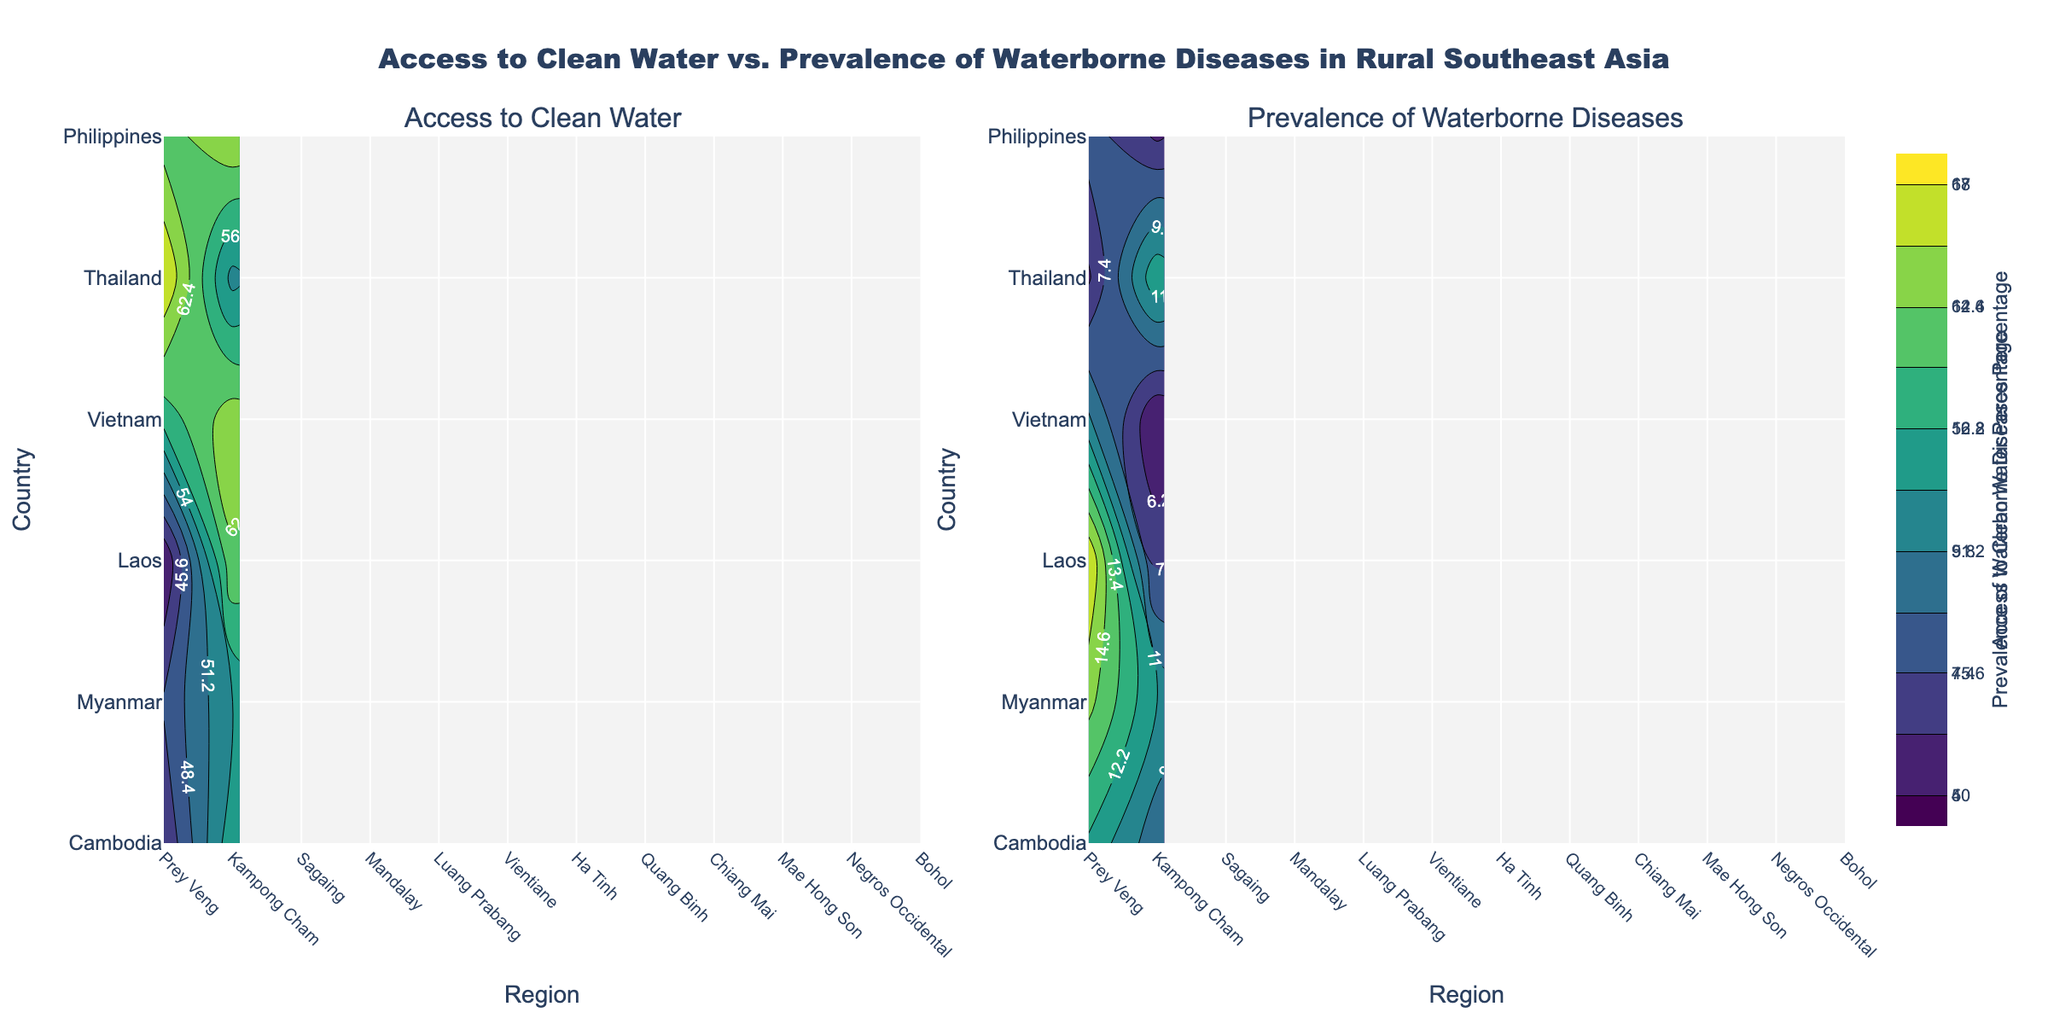What's the title of the figure? The title is usually located at the top of the figure and is meant to give an overview of what the graph represents. The title of this figure reads "Access to Clean Water vs. Prevalence of Waterborne Diseases in Rural Southeast Asia".
Answer: Access to Clean Water vs. Prevalence of Waterborne Diseases in Rural Southeast Asia How many subplots are there in the figure? The figure includes two subplots, one for "Access to Clean Water" and one for "Prevalence of Waterborne Diseases".
Answer: Two What are the x-axis and y-axis labels of the subplots? To understand the data plotted, it is essential to look at the axis labels. Both subplots share the same x-axis labeled "Region" and the y-axis labeled "Country".
Answer: Region, Country Which region shows the highest access to clean water? By analyzing the contour for "Access to Clean Water," we can identify the region with the highest values. The contour plot reveals that Quang Binh has the highest access to clean water at 64%.
Answer: Quang Binh Which country signals the highest prevalence of waterborne diseases? Looking at the contour plot for "Prevalence of Waterborne Diseases," the highest value represents the highest prevalence. Luang Prabang in Laos shows the highest prevalence at 17%.
Answer: Laos Compare the access to clean water between Cambodia’s Prey Veng and Kampong Cham regions. Which has higher access? By inspecting the contour plot for "Access to Clean Water," we can observe the values associated with these regions. Kampong Cham has higher access at 56% compared to Prey Veng at 43%.
Answer: Kampong Cham Calculate the average access to clean water percentage for regions in the Philippines. We need to find the regions in the Philippines and then compute their average access to clean water values. For Negros Occidental (61%) and Bohol (65%), the average is (61 + 65) / 2 = 63%.
Answer: 63% Which region in Thailand has a lower prevalence of waterborne diseases? By examining the contour plot for "Prevalence of Waterborne Diseases," Chiang Mai shows a lower prevalence at 6% compared to Mae Hong Son at 12%.
Answer: Chiang Mai Is there a correlation between access to clean water and prevalence of waterborne diseases in the regions presented? Compare and explain. By examining both contour plots, we notice regions with higher access to clean water generally have lower prevalence of waterborne diseases. For example, Quang Binh and Bohol have high access and low prevalence, while Luang Prabang has low access and high prevalence.
Answer: Negative correlation 